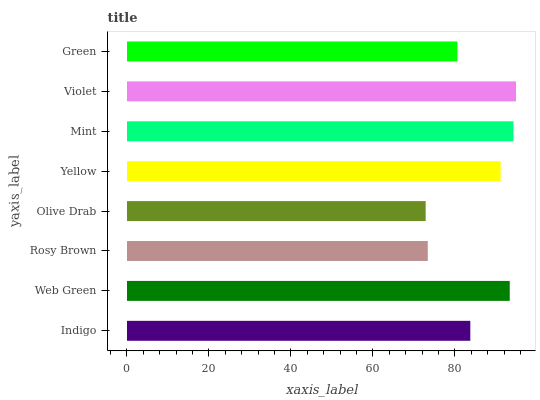Is Olive Drab the minimum?
Answer yes or no. Yes. Is Violet the maximum?
Answer yes or no. Yes. Is Web Green the minimum?
Answer yes or no. No. Is Web Green the maximum?
Answer yes or no. No. Is Web Green greater than Indigo?
Answer yes or no. Yes. Is Indigo less than Web Green?
Answer yes or no. Yes. Is Indigo greater than Web Green?
Answer yes or no. No. Is Web Green less than Indigo?
Answer yes or no. No. Is Yellow the high median?
Answer yes or no. Yes. Is Indigo the low median?
Answer yes or no. Yes. Is Rosy Brown the high median?
Answer yes or no. No. Is Web Green the low median?
Answer yes or no. No. 